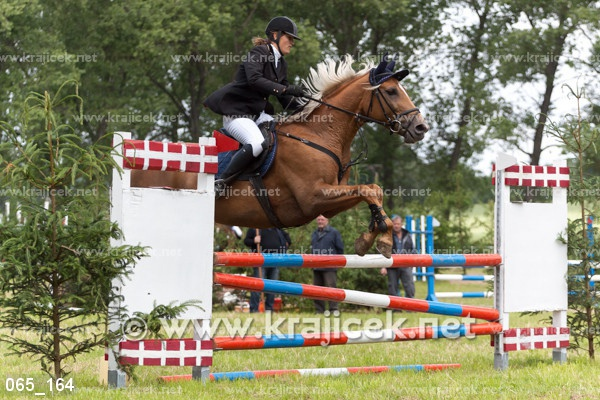Describe the objects in this image and their specific colors. I can see horse in olive, black, maroon, and gray tones, people in olive, black, gray, and lavender tones, people in olive, black, gray, and brown tones, people in olive, black, gray, and darkgreen tones, and people in olive, gray, and black tones in this image. 